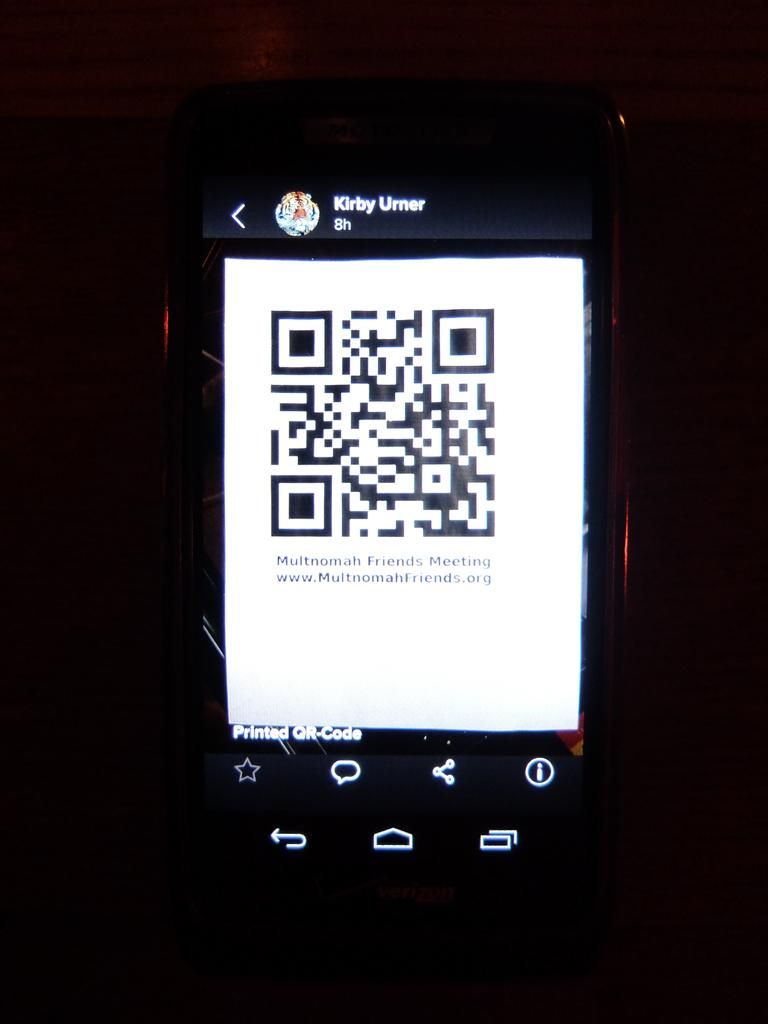What electronic device is visible in the image? There is a mobile phone in the image. What is displayed on the screen of the mobile phone? There is a QR code on the screen of the mobile phone. What type of lunch is being served on the snake in the image? There is no snake or lunch present in the image; it only features a mobile phone with a QR code on the screen. 